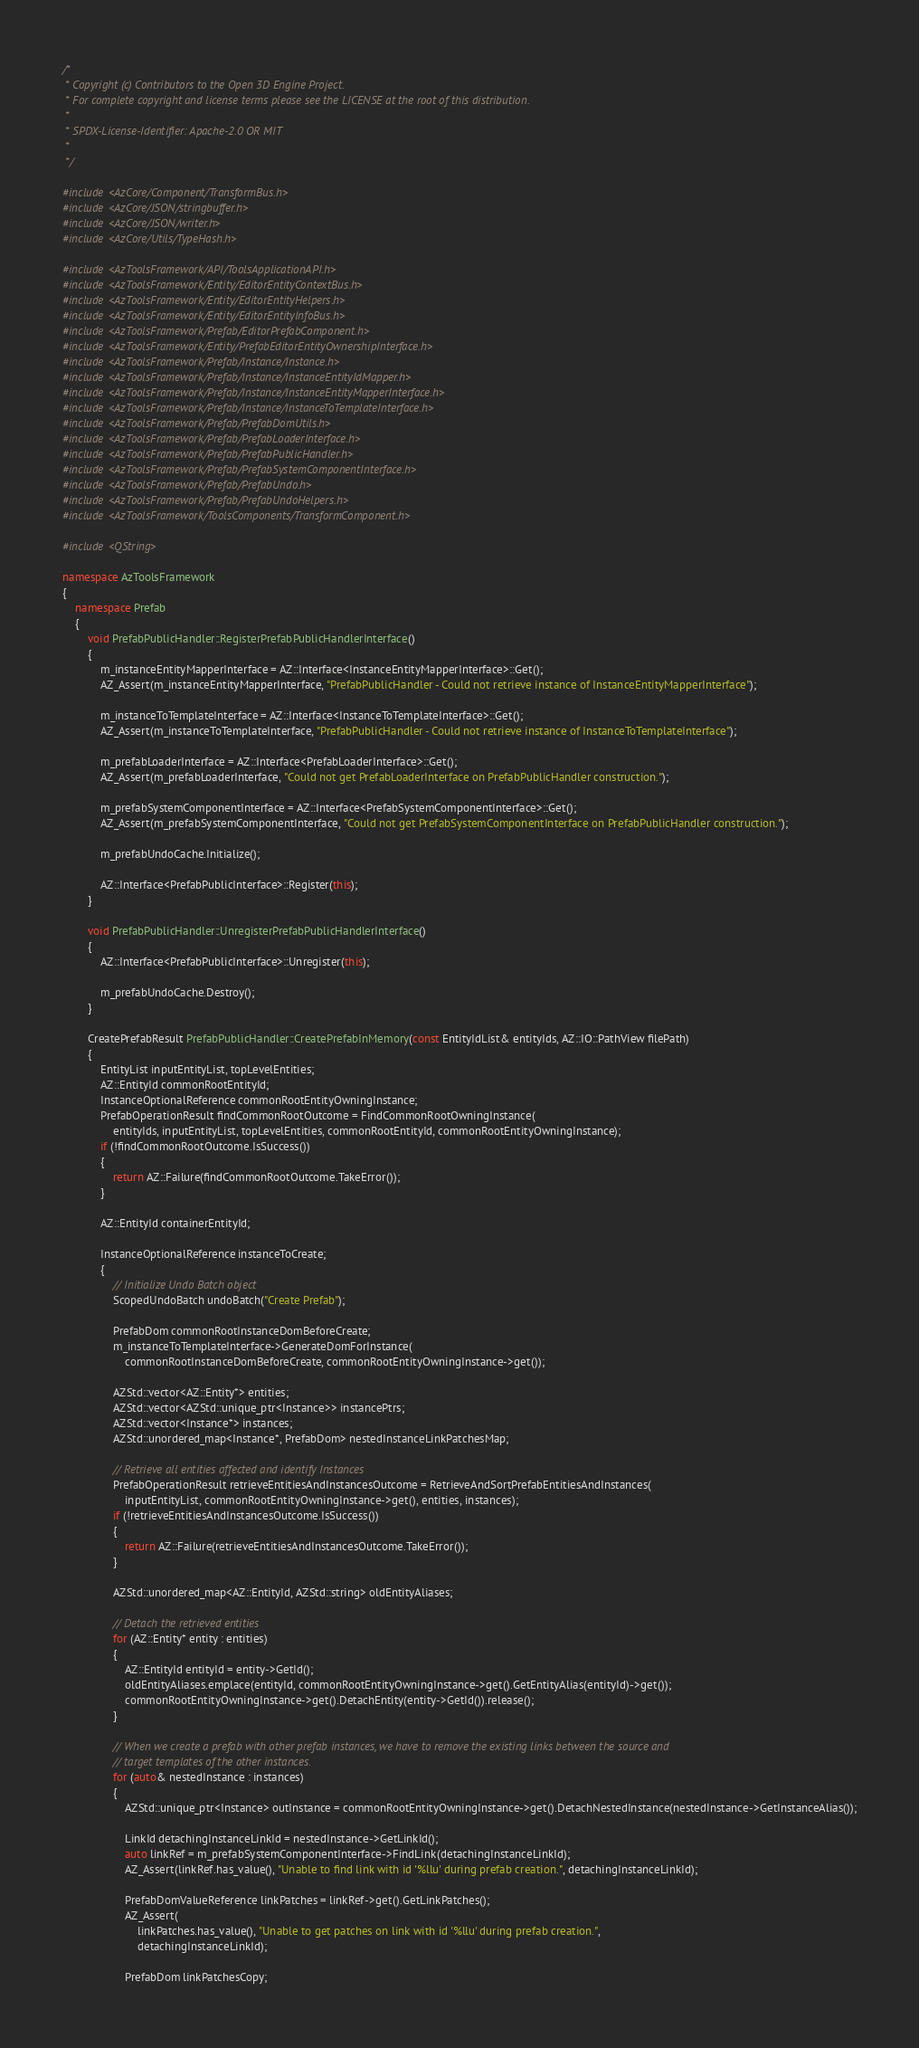Convert code to text. <code><loc_0><loc_0><loc_500><loc_500><_C++_>/*
 * Copyright (c) Contributors to the Open 3D Engine Project.
 * For complete copyright and license terms please see the LICENSE at the root of this distribution.
 *
 * SPDX-License-Identifier: Apache-2.0 OR MIT
 *
 */

#include <AzCore/Component/TransformBus.h>
#include <AzCore/JSON/stringbuffer.h>
#include <AzCore/JSON/writer.h>
#include <AzCore/Utils/TypeHash.h>

#include <AzToolsFramework/API/ToolsApplicationAPI.h>
#include <AzToolsFramework/Entity/EditorEntityContextBus.h>
#include <AzToolsFramework/Entity/EditorEntityHelpers.h>
#include <AzToolsFramework/Entity/EditorEntityInfoBus.h>
#include <AzToolsFramework/Prefab/EditorPrefabComponent.h>
#include <AzToolsFramework/Entity/PrefabEditorEntityOwnershipInterface.h>
#include <AzToolsFramework/Prefab/Instance/Instance.h>
#include <AzToolsFramework/Prefab/Instance/InstanceEntityIdMapper.h>
#include <AzToolsFramework/Prefab/Instance/InstanceEntityMapperInterface.h>
#include <AzToolsFramework/Prefab/Instance/InstanceToTemplateInterface.h>
#include <AzToolsFramework/Prefab/PrefabDomUtils.h>
#include <AzToolsFramework/Prefab/PrefabLoaderInterface.h>
#include <AzToolsFramework/Prefab/PrefabPublicHandler.h>
#include <AzToolsFramework/Prefab/PrefabSystemComponentInterface.h>
#include <AzToolsFramework/Prefab/PrefabUndo.h>
#include <AzToolsFramework/Prefab/PrefabUndoHelpers.h>
#include <AzToolsFramework/ToolsComponents/TransformComponent.h>

#include <QString>

namespace AzToolsFramework
{
    namespace Prefab
    {
        void PrefabPublicHandler::RegisterPrefabPublicHandlerInterface()
        {
            m_instanceEntityMapperInterface = AZ::Interface<InstanceEntityMapperInterface>::Get();
            AZ_Assert(m_instanceEntityMapperInterface, "PrefabPublicHandler - Could not retrieve instance of InstanceEntityMapperInterface");

            m_instanceToTemplateInterface = AZ::Interface<InstanceToTemplateInterface>::Get();
            AZ_Assert(m_instanceToTemplateInterface, "PrefabPublicHandler - Could not retrieve instance of InstanceToTemplateInterface");

            m_prefabLoaderInterface = AZ::Interface<PrefabLoaderInterface>::Get();
            AZ_Assert(m_prefabLoaderInterface, "Could not get PrefabLoaderInterface on PrefabPublicHandler construction.");

            m_prefabSystemComponentInterface = AZ::Interface<PrefabSystemComponentInterface>::Get();
            AZ_Assert(m_prefabSystemComponentInterface, "Could not get PrefabSystemComponentInterface on PrefabPublicHandler construction.");

            m_prefabUndoCache.Initialize();

            AZ::Interface<PrefabPublicInterface>::Register(this);
        }

        void PrefabPublicHandler::UnregisterPrefabPublicHandlerInterface()
        {
            AZ::Interface<PrefabPublicInterface>::Unregister(this);

            m_prefabUndoCache.Destroy();
        }

        CreatePrefabResult PrefabPublicHandler::CreatePrefabInMemory(const EntityIdList& entityIds, AZ::IO::PathView filePath)
        {
            EntityList inputEntityList, topLevelEntities;
            AZ::EntityId commonRootEntityId;
            InstanceOptionalReference commonRootEntityOwningInstance;
            PrefabOperationResult findCommonRootOutcome = FindCommonRootOwningInstance(
                entityIds, inputEntityList, topLevelEntities, commonRootEntityId, commonRootEntityOwningInstance);
            if (!findCommonRootOutcome.IsSuccess())
            {
                return AZ::Failure(findCommonRootOutcome.TakeError());
            }

            AZ::EntityId containerEntityId;

            InstanceOptionalReference instanceToCreate;
            {
                // Initialize Undo Batch object
                ScopedUndoBatch undoBatch("Create Prefab");

                PrefabDom commonRootInstanceDomBeforeCreate;
                m_instanceToTemplateInterface->GenerateDomForInstance(
                    commonRootInstanceDomBeforeCreate, commonRootEntityOwningInstance->get());

                AZStd::vector<AZ::Entity*> entities;
                AZStd::vector<AZStd::unique_ptr<Instance>> instancePtrs;
                AZStd::vector<Instance*> instances;
                AZStd::unordered_map<Instance*, PrefabDom> nestedInstanceLinkPatchesMap;

                // Retrieve all entities affected and identify Instances
                PrefabOperationResult retrieveEntitiesAndInstancesOutcome = RetrieveAndSortPrefabEntitiesAndInstances(
                    inputEntityList, commonRootEntityOwningInstance->get(), entities, instances);
                if (!retrieveEntitiesAndInstancesOutcome.IsSuccess())
                {
                    return AZ::Failure(retrieveEntitiesAndInstancesOutcome.TakeError());
                }

                AZStd::unordered_map<AZ::EntityId, AZStd::string> oldEntityAliases;

                // Detach the retrieved entities
                for (AZ::Entity* entity : entities)
                {
                    AZ::EntityId entityId = entity->GetId();
                    oldEntityAliases.emplace(entityId, commonRootEntityOwningInstance->get().GetEntityAlias(entityId)->get());
                    commonRootEntityOwningInstance->get().DetachEntity(entity->GetId()).release();
                }

                // When we create a prefab with other prefab instances, we have to remove the existing links between the source and 
                // target templates of the other instances.
                for (auto& nestedInstance : instances)
                {
                    AZStd::unique_ptr<Instance> outInstance = commonRootEntityOwningInstance->get().DetachNestedInstance(nestedInstance->GetInstanceAlias());

                    LinkId detachingInstanceLinkId = nestedInstance->GetLinkId();
                    auto linkRef = m_prefabSystemComponentInterface->FindLink(detachingInstanceLinkId);
                    AZ_Assert(linkRef.has_value(), "Unable to find link with id '%llu' during prefab creation.", detachingInstanceLinkId);

                    PrefabDomValueReference linkPatches = linkRef->get().GetLinkPatches();
                    AZ_Assert(
                        linkPatches.has_value(), "Unable to get patches on link with id '%llu' during prefab creation.",
                        detachingInstanceLinkId);

                    PrefabDom linkPatchesCopy;</code> 